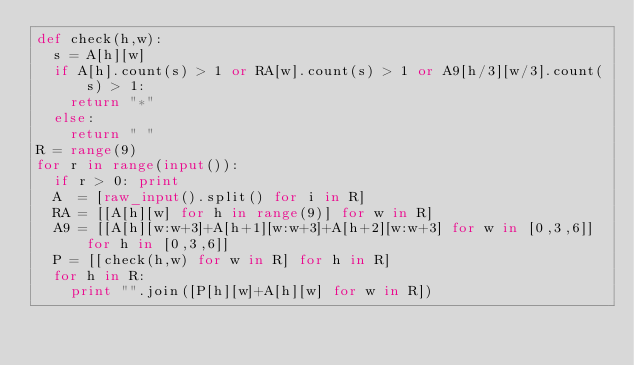<code> <loc_0><loc_0><loc_500><loc_500><_Python_>def check(h,w):
	s = A[h][w]
	if A[h].count(s) > 1 or RA[w].count(s) > 1 or A9[h/3][w/3].count(s) > 1:
		return "*"
	else:
		return " "
R = range(9)
for r in range(input()):
	if r > 0: print
	A  = [raw_input().split() for i in R]
	RA = [[A[h][w] for h in range(9)] for w in R] 
	A9 = [[A[h][w:w+3]+A[h+1][w:w+3]+A[h+2][w:w+3] for w in [0,3,6]] for h in [0,3,6]]
	P = [[check(h,w) for w in R] for h in R] 
	for h in R:
		print "".join([P[h][w]+A[h][w] for w in R])</code> 